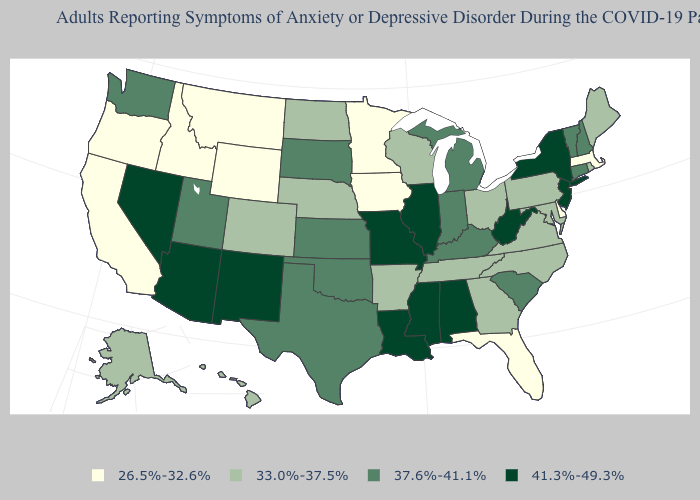What is the value of Connecticut?
Give a very brief answer. 37.6%-41.1%. What is the lowest value in states that border California?
Concise answer only. 26.5%-32.6%. Is the legend a continuous bar?
Concise answer only. No. Name the states that have a value in the range 37.6%-41.1%?
Quick response, please. Connecticut, Indiana, Kansas, Kentucky, Michigan, New Hampshire, Oklahoma, South Carolina, South Dakota, Texas, Utah, Vermont, Washington. Name the states that have a value in the range 37.6%-41.1%?
Answer briefly. Connecticut, Indiana, Kansas, Kentucky, Michigan, New Hampshire, Oklahoma, South Carolina, South Dakota, Texas, Utah, Vermont, Washington. What is the value of Wisconsin?
Keep it brief. 33.0%-37.5%. What is the lowest value in the USA?
Keep it brief. 26.5%-32.6%. Name the states that have a value in the range 26.5%-32.6%?
Short answer required. California, Delaware, Florida, Idaho, Iowa, Massachusetts, Minnesota, Montana, Oregon, Wyoming. What is the value of Hawaii?
Answer briefly. 33.0%-37.5%. Name the states that have a value in the range 33.0%-37.5%?
Give a very brief answer. Alaska, Arkansas, Colorado, Georgia, Hawaii, Maine, Maryland, Nebraska, North Carolina, North Dakota, Ohio, Pennsylvania, Rhode Island, Tennessee, Virginia, Wisconsin. What is the value of Colorado?
Concise answer only. 33.0%-37.5%. What is the value of Texas?
Quick response, please. 37.6%-41.1%. What is the value of South Carolina?
Concise answer only. 37.6%-41.1%. Which states have the lowest value in the USA?
Give a very brief answer. California, Delaware, Florida, Idaho, Iowa, Massachusetts, Minnesota, Montana, Oregon, Wyoming. 